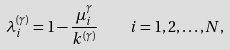<formula> <loc_0><loc_0><loc_500><loc_500>\lambda _ { i } ^ { ( \gamma ) } = 1 - \frac { \mu _ { i } ^ { \gamma } } { k ^ { ( \gamma ) } } \quad i = 1 , 2 , \dots , N ,</formula> 